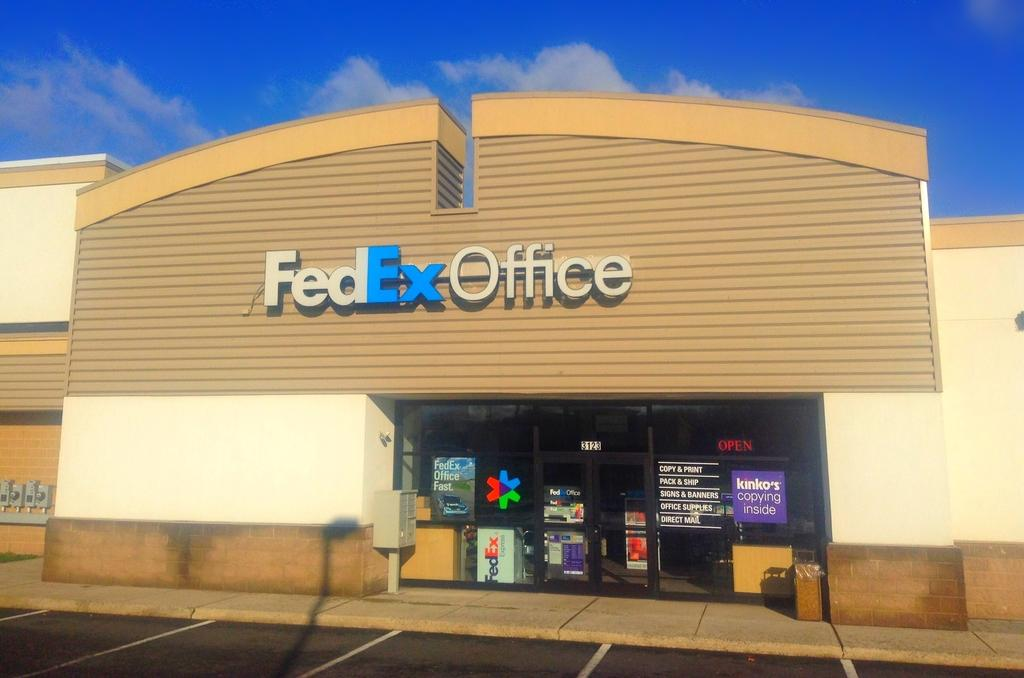What type of structure is present in the image? There is a building in the image. What is written on the building? The building has "FedEX Office" written on it. What type of lunch is being served at the building in the image? There is no information about lunch or any food being served in the image. 